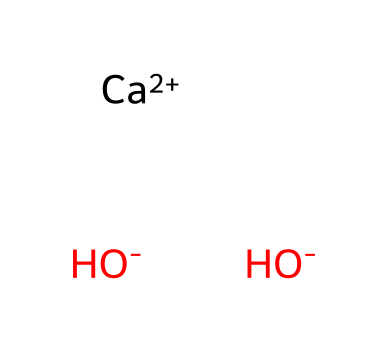What is the name of this chemical? The SMILES representation indicates that the chemical consists of calcium ions and hydroxide ions, which is known as calcium hydroxide.
Answer: calcium hydroxide How many hydroxide ions are present in this compound? In the SMILES representation, the hydroxide ions are indicated by [OH-]. There are two instances of this grouping, which means there are two hydroxide ions.
Answer: 2 What is the charge of the calcium ion in this chemical? The calcium ion is represented as [Ca+2], indicating that it carries a +2 charge.
Answer: +2 What type of compound is calcium hydroxide classified as? Calcium hydroxide is classified as a base due to its ability to accept protons and its hydroxide content.
Answer: base How many types of atoms are present in this chemical? The SMILES shows calcium (Ca), oxygen (O), and hydrogen (H). This yields three unique types of atoms: one calcium, two oxygen, and two hydrogen atoms.
Answer: 3 Is calcium hydroxide soluble in water? Calcium hydroxide is known to have low solubility in water, which can be deduced from its ionic structure and the presence of the hydroxide groups.
Answer: yes Why is calcium hydroxide used in stage paints and plasters? Calcium hydroxide provides a strong base that can help bind pigments and improve durability when used in paints and plasters. Its alkaline nature contributes to the preservation of materials.
Answer: binding agent 